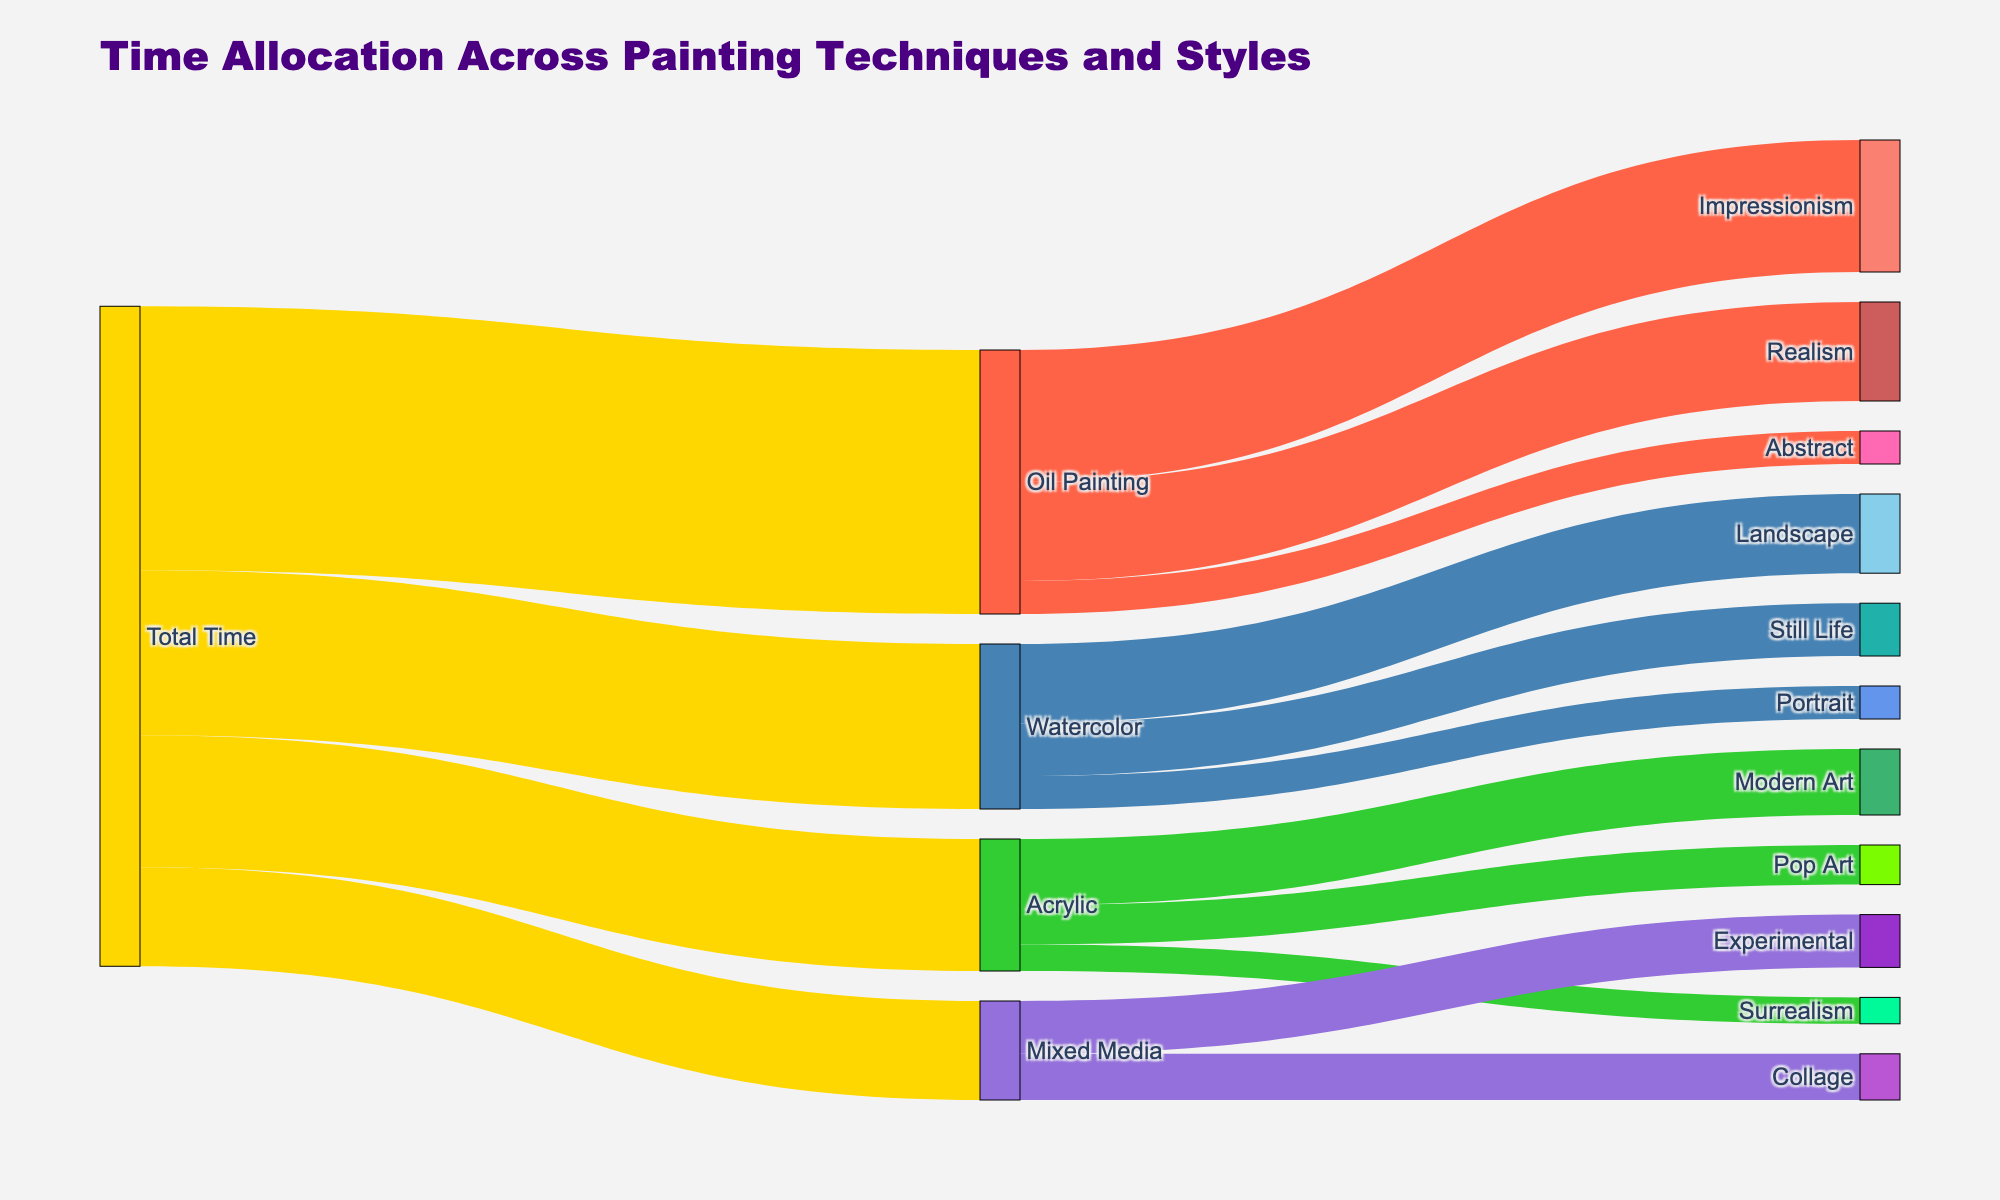What is the total time allocated to painting techniques? The total time corresponds to the sum of values from "Total Time" to each technique, which is 40 (Oil Painting) + 25 (Watercolor) + 20 (Acrylic) + 15 (Mixed Media)
Answer: 100 Which painting technique has the highest allocated time? By comparing the values from "Total Time" to each technique, Oil Painting has the highest value at 40.
Answer: Oil Painting How much time is allocated to Realism under Oil Painting? The flow from Oil Painting to Realism shows a value of 15, as indicated in the figure.
Answer: 15 What is the total time allocated to Abstract and Collage combined? The value allocated to Abstract is 5, and to Collage is 7. Summing these two values: 5 + 7 = 12
Answer: 12 Which style has the least allocated time under Watercolor? Comparing the branches under Watercolor: Landscape (12), Still Life (8), and Portrait (5). Portrait has the least time allocated.
Answer: Portrait How much more time is allocated to Impressionism compared to Abstract under Oil Painting? Impressionism has 20 units of time and Abstract has 5. The difference between them is 20 - 5 = 15
Answer: 15 What style receives the most time in Acrylic painting? From the Acrylic branches, Modern Art has 10, Pop Art 6, and Surrealism 4. Modern Art has the most time.
Answer: Modern Art How does the time allocation for Experimental in Mixed Media compare to Realism in Oil Painting? Experimental has 8 and Realism in Oil Painting has 15. Comparing these: Realism has more time allocated.
Answer: Realism in Oil Painting What's the combined allocated time for Still Life and Pop Art? Still Life has 8 and Pop Art has 6. Summing these: 8 + 6 = 14
Answer: 14 Which techniques and styles have an equal time allocation to Pop Art? Pop Art under Acrylic is allocated 6 units. Portrait under Watercolor also has 5 units, but there are no exact matches with 6 units.
Answer: None 